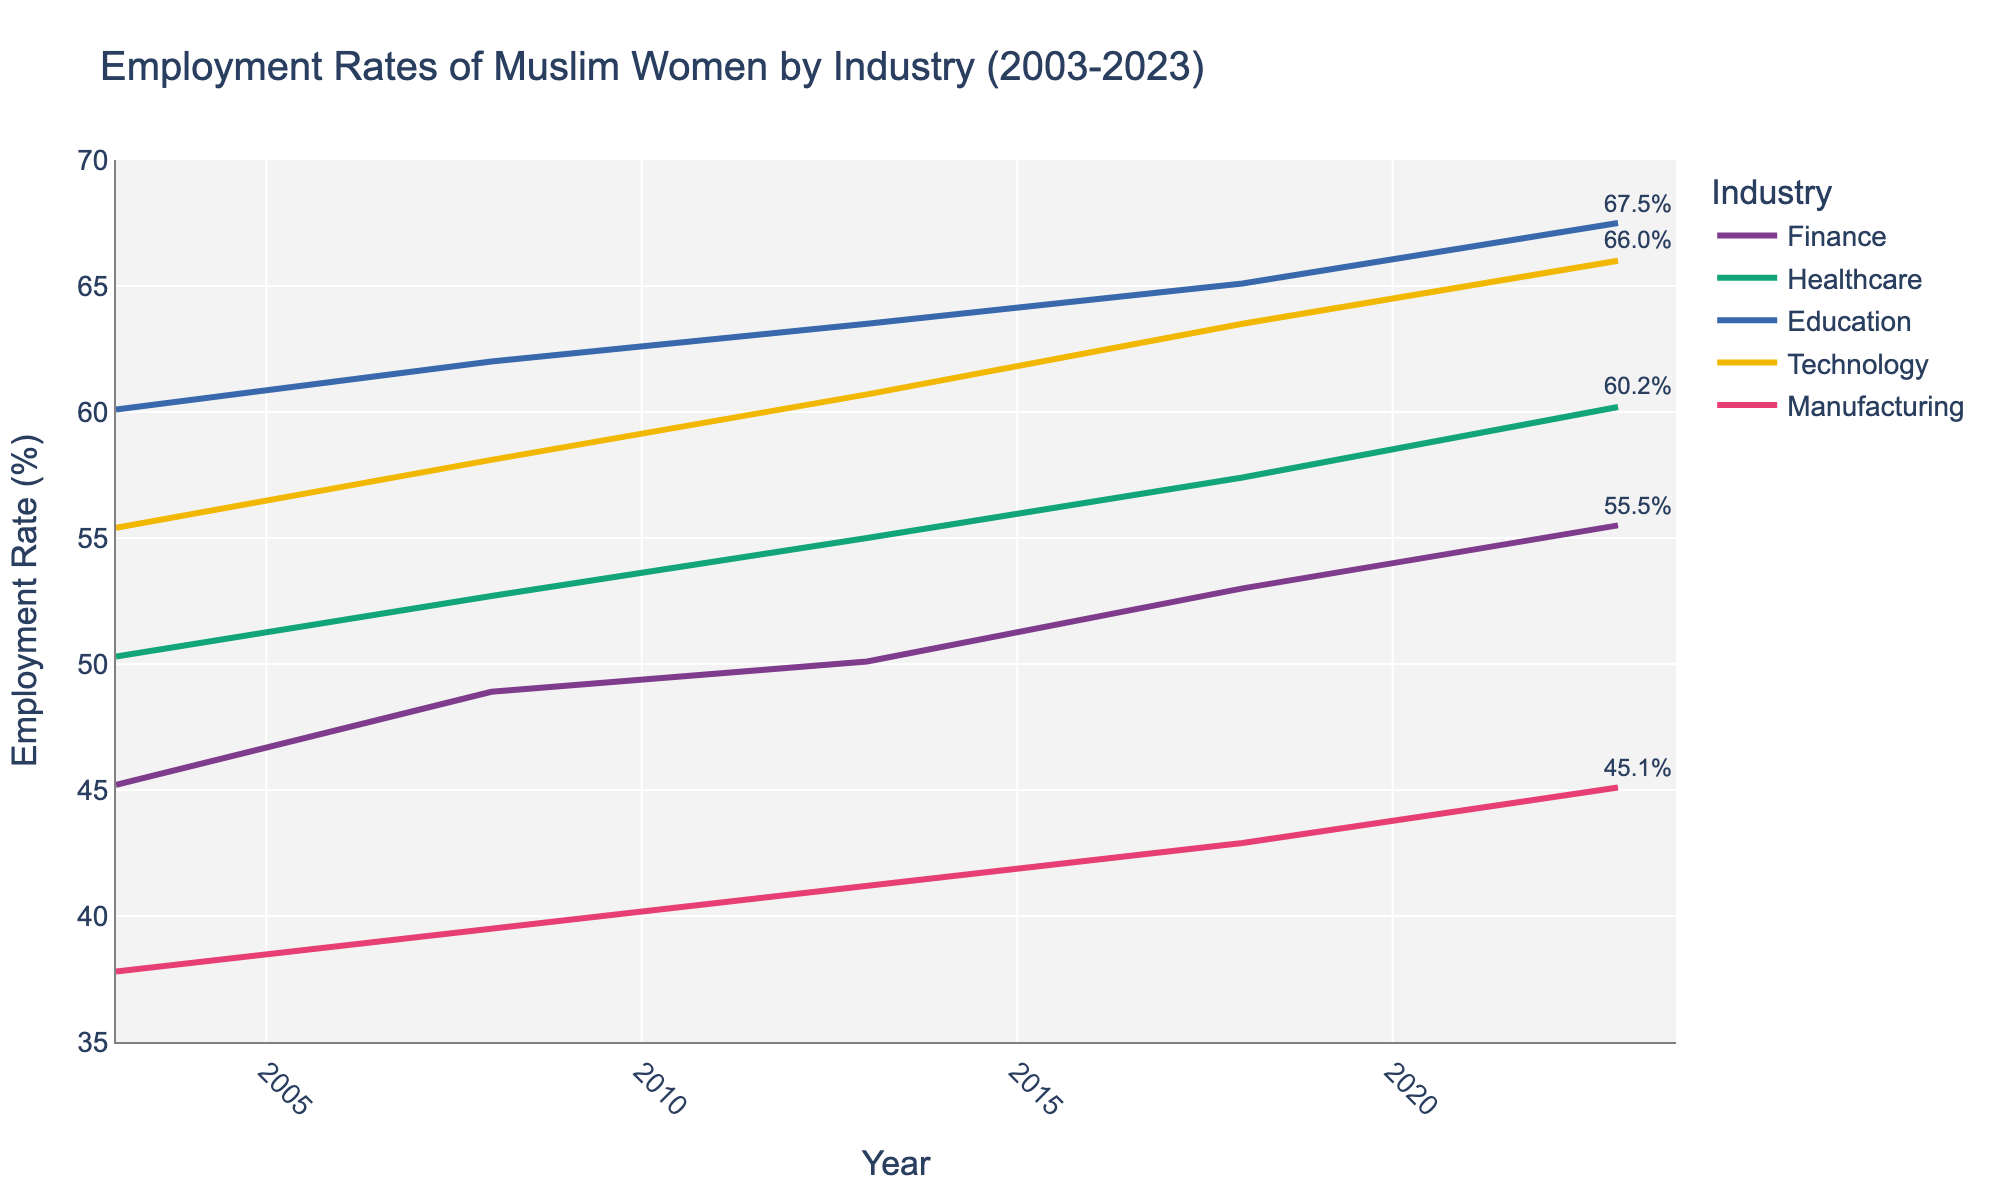What's the title of the figure? The title of the figure is usually placed at the top and summarizes the main focus of the data presented. In this case, the title is "Employment Rates of Muslim Women by Industry (2003-2023)."
Answer: Employment Rates of Muslim Women by Industry (2003-2023) What are the industries shown in the plot? The industries can be identified by the legend on the right-hand side of the figure or by the labels within the graph. The industries shown are Finance, Healthcare, Education, Technology, and Manufacturing.
Answer: Finance, Healthcare, Education, Technology, Manufacturing Which industry shows the highest employment rate in 2023? By looking at the end of the plot, where the latest year (2023) is located, you can observe the employment rate for each industry. The highest employment rate in 2023 is for the Education industry.
Answer: Education How has the employment rate in the Manufacturing industry changed over the past 20 years? Trace the line representing Manufacturing from the start (2003) to the end (2023). The line shows a gradual increase from 37.8% in 2003 to 45.1% in 2023.
Answer: It has increased from 37.8% to 45.1% Between which years did the Technology industry see the most significant increase in employment rates? Find the steepest slope in the Technology line graph by observing the changes between consecutive years. The most significant increase appears between 2018 and 2023, where the rate goes from 63.5% to 66.0%.
Answer: 2018 to 2023 What is the overall trend in employment rates for Muslim women in the Healthcare industry? Follow the line representing Healthcare from the start year (2003) to the end year (2023). The line shows a consistent upward trend, increasing from 50.3% in 2003 to 60.2% in 2023.
Answer: Upward trend Which two industries had the closest employment rates in 2008? Find the data points for the year 2008 and compare the employment rates. The Finance (48.9%) and Manufacturing (39.5%) industries were the closest that year, but Education (62.0%) and Technology (58.1%) are closer compared to others.
Answer: Education and Technology How does the 2023 employment rate in Finance compare to that in 2003? Compare the employment rates for Finance in the years 2023 (55.5%) and 2003 (45.2%) by noting where these values fall on the y-axis. The rate has increased.
Answer: It has increased by 10.3% What is the approximate average employment rate for Education over the 20 years? Calculate the average for the employment rates in Education: (60.1 + 62.0 + 63.5 + 65.1 + 67.5) / 5. This equals to (60.1 + 62.0 + 63.5 + 65.1 + 67.5) = 318.2 / 5.
Answer: 63.64 